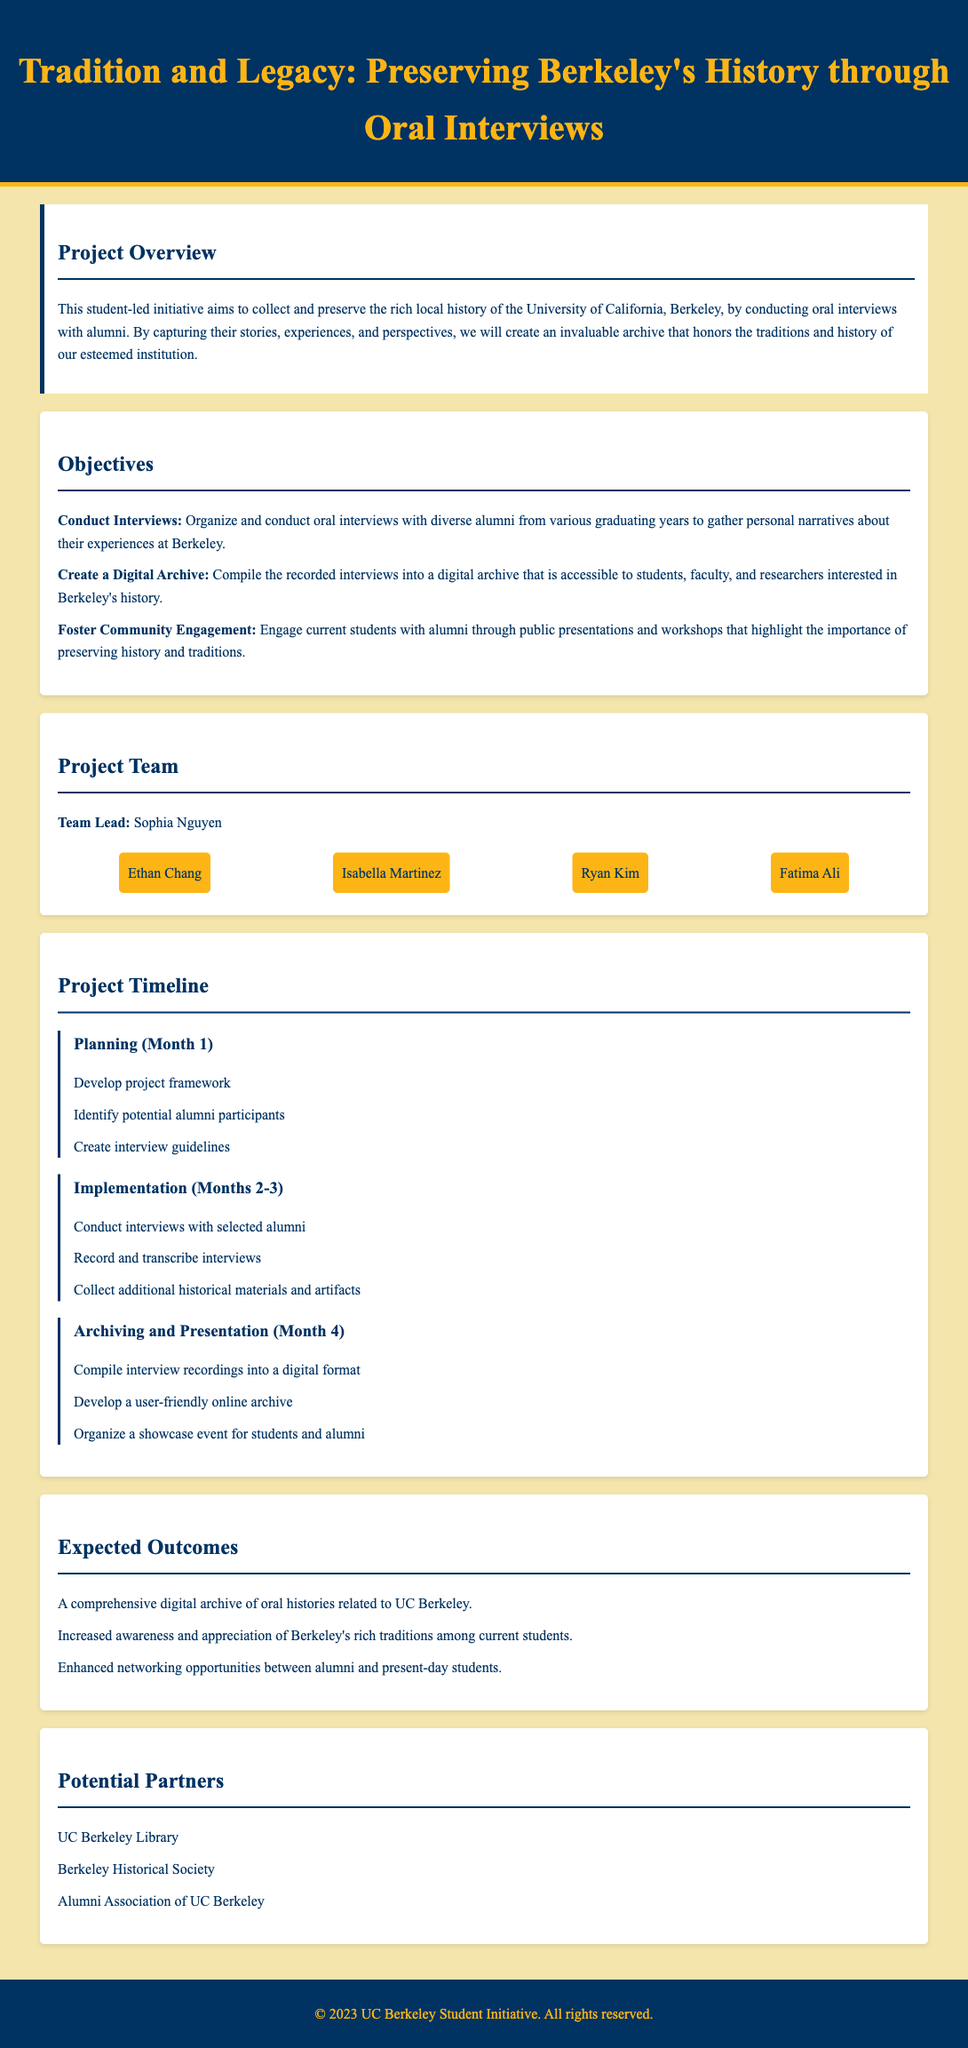What is the title of the project? The title can be found in the header section of the document, which states "Tradition and Legacy: Preserving Berkeley's History through Oral Interviews."
Answer: Tradition and Legacy: Preserving Berkeley's History through Oral Interviews Who is the team lead for the project? The team lead is specified in the project team section as Sophia Nguyen.
Answer: Sophia Nguyen How many team members are listed in total? The project team section lists four team members in addition to the team lead.
Answer: 5 What phase occurs in Month 4? The project timeline section details that "Archiving and Presentation" occurs in Month 4.
Answer: Archiving and Presentation What is one objective of the project? The objectives section provides several objectives, one being to "Organize and conduct oral interviews with diverse alumni."
Answer: Organize and conduct oral interviews Which organization is listed as a potential partner? The potential partners section lists the "UC Berkeley Library" as one of the partners.
Answer: UC Berkeley Library What is one expected outcome of the project? The expected outcomes section states a comprehensive digital archive of oral histories related to UC Berkeley as an outcome.
Answer: A comprehensive digital archive of oral histories In how many months is the Implementation phase scheduled? The project timeline specifies the Implementation phase is scheduled for "Months 2-3," indicating a duration of two months.
Answer: 2 months 